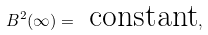<formula> <loc_0><loc_0><loc_500><loc_500>B ^ { 2 } ( \infty ) = \text { constant} ,</formula> 